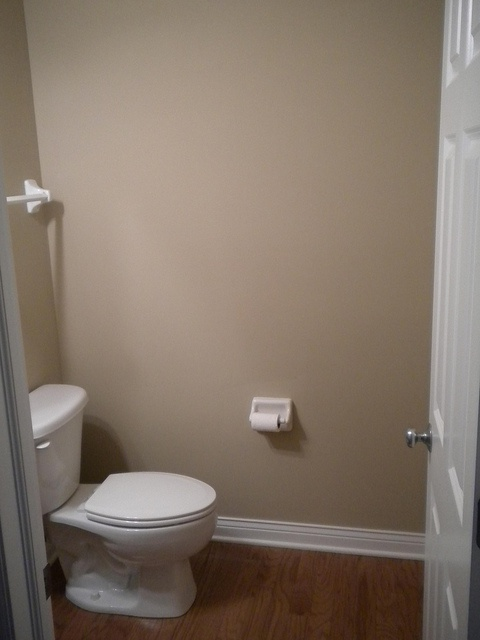Describe the objects in this image and their specific colors. I can see a toilet in gray, darkgray, and black tones in this image. 